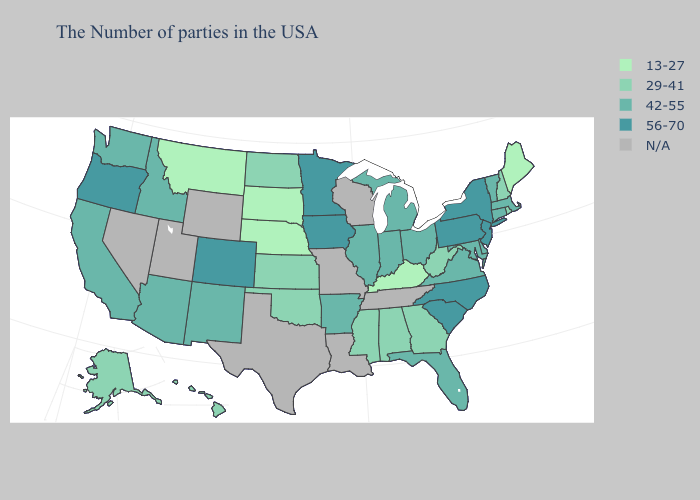What is the value of Ohio?
Short answer required. 42-55. What is the highest value in the USA?
Answer briefly. 56-70. Among the states that border Washington , does Idaho have the highest value?
Write a very short answer. No. What is the value of Pennsylvania?
Quick response, please. 56-70. What is the highest value in states that border North Dakota?
Answer briefly. 56-70. What is the value of Idaho?
Concise answer only. 42-55. What is the value of Montana?
Give a very brief answer. 13-27. Name the states that have a value in the range 29-41?
Answer briefly. Rhode Island, New Hampshire, West Virginia, Georgia, Alabama, Mississippi, Kansas, Oklahoma, North Dakota, Alaska, Hawaii. What is the value of West Virginia?
Write a very short answer. 29-41. Name the states that have a value in the range 13-27?
Answer briefly. Maine, Kentucky, Nebraska, South Dakota, Montana. Which states have the lowest value in the USA?
Be succinct. Maine, Kentucky, Nebraska, South Dakota, Montana. Name the states that have a value in the range 29-41?
Keep it brief. Rhode Island, New Hampshire, West Virginia, Georgia, Alabama, Mississippi, Kansas, Oklahoma, North Dakota, Alaska, Hawaii. What is the value of Arizona?
Short answer required. 42-55. 